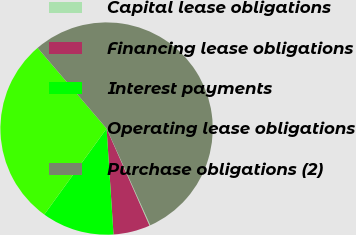Convert chart. <chart><loc_0><loc_0><loc_500><loc_500><pie_chart><fcel>Capital lease obligations<fcel>Financing lease obligations<fcel>Interest payments<fcel>Operating lease obligations<fcel>Purchase obligations (2)<nl><fcel>0.14%<fcel>5.58%<fcel>11.02%<fcel>28.76%<fcel>54.5%<nl></chart> 